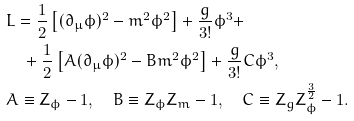Convert formula to latex. <formula><loc_0><loc_0><loc_500><loc_500>& L = \frac { 1 } { 2 } \left [ ( \partial _ { \mu } \phi ) ^ { 2 } - m ^ { 2 } \phi ^ { 2 } \right ] + \frac { g } { 3 ! } \phi ^ { 3 } + \\ & \quad + \frac { 1 } { 2 } \left [ A ( \partial _ { \mu } \phi ) ^ { 2 } - B m ^ { 2 } \phi ^ { 2 } \right ] + \frac { g } { 3 ! } C \phi ^ { 3 } , \\ & A \equiv Z _ { \phi } - 1 , \quad B \equiv Z _ { \phi } Z _ { m } - 1 , \quad C \equiv Z _ { g } Z _ { \phi } ^ { \frac { 3 } { 2 } } - 1 .</formula> 